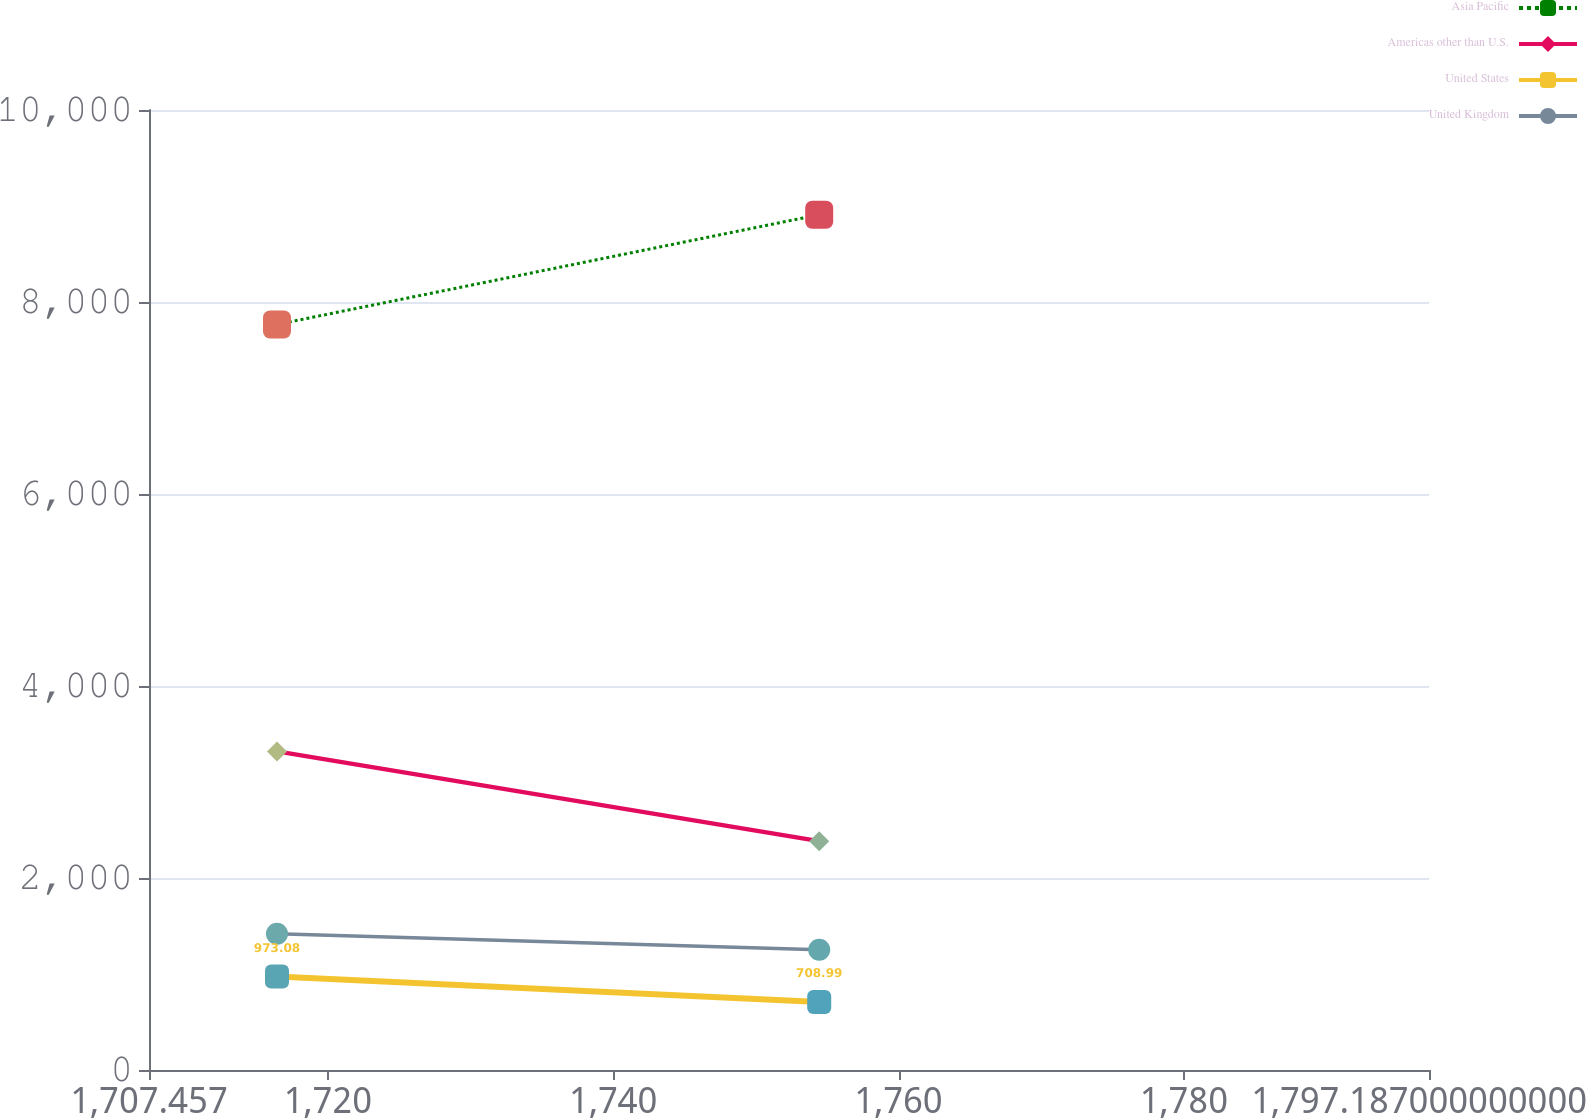Convert chart. <chart><loc_0><loc_0><loc_500><loc_500><line_chart><ecel><fcel>Asia Pacific<fcel>Americas other than U.S.<fcel>United States<fcel>United Kingdom<nl><fcel>1716.43<fcel>7765.95<fcel>3318.76<fcel>973.08<fcel>1419.8<nl><fcel>1754.44<fcel>8909.35<fcel>2383.86<fcel>708.99<fcel>1251.99<nl><fcel>1806.16<fcel>7457.43<fcel>2792.72<fcel>826.09<fcel>1527.27<nl></chart> 